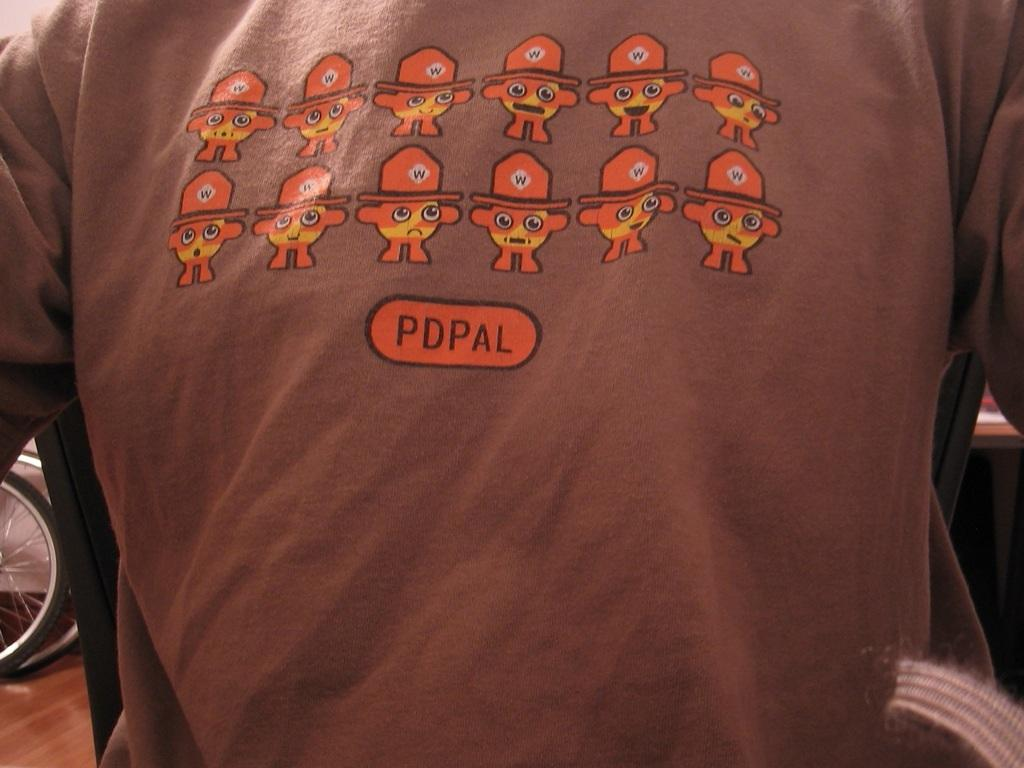What is the main object in the image? There is a cloth in the image. What color is the cloth? The cloth is brown in color. Can you describe any patterns or designs on the cloth? Yes, there is a design on the cloth. Is there any text present on the cloth? Yes, there is text on the cloth. What type of trail can be seen on the cloth in the image? There is no trail visible on the cloth in the image. 